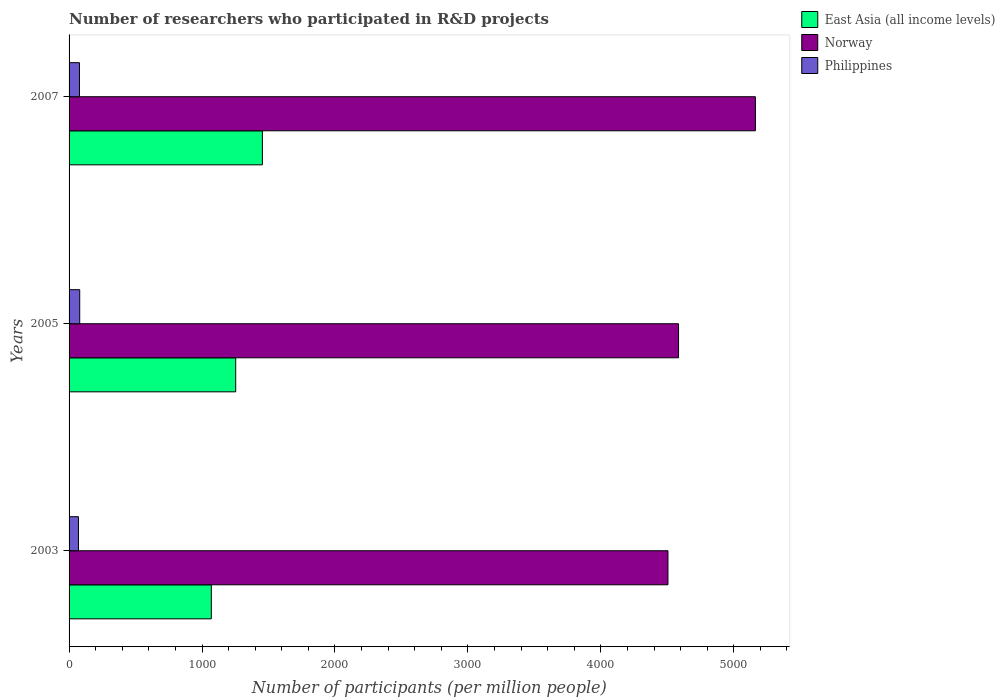How many groups of bars are there?
Ensure brevity in your answer.  3. Are the number of bars on each tick of the Y-axis equal?
Offer a very short reply. Yes. In how many cases, is the number of bars for a given year not equal to the number of legend labels?
Provide a short and direct response. 0. What is the number of researchers who participated in R&D projects in Philippines in 2003?
Make the answer very short. 70.63. Across all years, what is the maximum number of researchers who participated in R&D projects in Norway?
Offer a terse response. 5162.76. Across all years, what is the minimum number of researchers who participated in R&D projects in Philippines?
Provide a short and direct response. 70.63. In which year was the number of researchers who participated in R&D projects in Norway maximum?
Your answer should be very brief. 2007. What is the total number of researchers who participated in R&D projects in Norway in the graph?
Your response must be concise. 1.43e+04. What is the difference between the number of researchers who participated in R&D projects in Philippines in 2003 and that in 2005?
Offer a terse response. -9.43. What is the difference between the number of researchers who participated in R&D projects in East Asia (all income levels) in 2005 and the number of researchers who participated in R&D projects in Philippines in 2007?
Make the answer very short. 1175.22. What is the average number of researchers who participated in R&D projects in East Asia (all income levels) per year?
Provide a succinct answer. 1259.26. In the year 2003, what is the difference between the number of researchers who participated in R&D projects in East Asia (all income levels) and number of researchers who participated in R&D projects in Norway?
Your answer should be compact. -3434.84. In how many years, is the number of researchers who participated in R&D projects in East Asia (all income levels) greater than 200 ?
Ensure brevity in your answer.  3. What is the ratio of the number of researchers who participated in R&D projects in Norway in 2005 to that in 2007?
Ensure brevity in your answer.  0.89. Is the number of researchers who participated in R&D projects in East Asia (all income levels) in 2003 less than that in 2005?
Ensure brevity in your answer.  Yes. Is the difference between the number of researchers who participated in R&D projects in East Asia (all income levels) in 2003 and 2005 greater than the difference between the number of researchers who participated in R&D projects in Norway in 2003 and 2005?
Your answer should be very brief. No. What is the difference between the highest and the second highest number of researchers who participated in R&D projects in Norway?
Make the answer very short. 578.31. What is the difference between the highest and the lowest number of researchers who participated in R&D projects in East Asia (all income levels)?
Provide a short and direct response. 384.15. What does the 3rd bar from the top in 2005 represents?
Ensure brevity in your answer.  East Asia (all income levels). What does the 2nd bar from the bottom in 2007 represents?
Your answer should be very brief. Norway. Are all the bars in the graph horizontal?
Offer a very short reply. Yes. How many years are there in the graph?
Ensure brevity in your answer.  3. What is the difference between two consecutive major ticks on the X-axis?
Give a very brief answer. 1000. Does the graph contain any zero values?
Your response must be concise. No. Where does the legend appear in the graph?
Provide a short and direct response. Top right. How many legend labels are there?
Keep it short and to the point. 3. What is the title of the graph?
Keep it short and to the point. Number of researchers who participated in R&D projects. Does "Zambia" appear as one of the legend labels in the graph?
Offer a terse response. No. What is the label or title of the X-axis?
Provide a short and direct response. Number of participants (per million people). What is the label or title of the Y-axis?
Offer a very short reply. Years. What is the Number of participants (per million people) of East Asia (all income levels) in 2003?
Your answer should be very brief. 1070.1. What is the Number of participants (per million people) in Norway in 2003?
Provide a short and direct response. 4504.94. What is the Number of participants (per million people) of Philippines in 2003?
Your answer should be very brief. 70.63. What is the Number of participants (per million people) of East Asia (all income levels) in 2005?
Your response must be concise. 1253.42. What is the Number of participants (per million people) in Norway in 2005?
Your response must be concise. 4584.46. What is the Number of participants (per million people) of Philippines in 2005?
Provide a succinct answer. 80.05. What is the Number of participants (per million people) in East Asia (all income levels) in 2007?
Provide a succinct answer. 1454.25. What is the Number of participants (per million people) of Norway in 2007?
Ensure brevity in your answer.  5162.76. What is the Number of participants (per million people) of Philippines in 2007?
Your answer should be compact. 78.2. Across all years, what is the maximum Number of participants (per million people) of East Asia (all income levels)?
Provide a short and direct response. 1454.25. Across all years, what is the maximum Number of participants (per million people) in Norway?
Provide a succinct answer. 5162.76. Across all years, what is the maximum Number of participants (per million people) in Philippines?
Offer a very short reply. 80.05. Across all years, what is the minimum Number of participants (per million people) in East Asia (all income levels)?
Make the answer very short. 1070.1. Across all years, what is the minimum Number of participants (per million people) of Norway?
Keep it short and to the point. 4504.94. Across all years, what is the minimum Number of participants (per million people) of Philippines?
Offer a terse response. 70.63. What is the total Number of participants (per million people) of East Asia (all income levels) in the graph?
Give a very brief answer. 3777.77. What is the total Number of participants (per million people) in Norway in the graph?
Offer a very short reply. 1.43e+04. What is the total Number of participants (per million people) in Philippines in the graph?
Make the answer very short. 228.88. What is the difference between the Number of participants (per million people) in East Asia (all income levels) in 2003 and that in 2005?
Your answer should be very brief. -183.32. What is the difference between the Number of participants (per million people) of Norway in 2003 and that in 2005?
Give a very brief answer. -79.51. What is the difference between the Number of participants (per million people) in Philippines in 2003 and that in 2005?
Your answer should be compact. -9.43. What is the difference between the Number of participants (per million people) of East Asia (all income levels) in 2003 and that in 2007?
Your answer should be compact. -384.15. What is the difference between the Number of participants (per million people) in Norway in 2003 and that in 2007?
Provide a succinct answer. -657.82. What is the difference between the Number of participants (per million people) of Philippines in 2003 and that in 2007?
Provide a succinct answer. -7.57. What is the difference between the Number of participants (per million people) of East Asia (all income levels) in 2005 and that in 2007?
Provide a succinct answer. -200.83. What is the difference between the Number of participants (per million people) in Norway in 2005 and that in 2007?
Your response must be concise. -578.31. What is the difference between the Number of participants (per million people) of Philippines in 2005 and that in 2007?
Your answer should be compact. 1.86. What is the difference between the Number of participants (per million people) of East Asia (all income levels) in 2003 and the Number of participants (per million people) of Norway in 2005?
Make the answer very short. -3514.36. What is the difference between the Number of participants (per million people) in East Asia (all income levels) in 2003 and the Number of participants (per million people) in Philippines in 2005?
Give a very brief answer. 990.04. What is the difference between the Number of participants (per million people) of Norway in 2003 and the Number of participants (per million people) of Philippines in 2005?
Keep it short and to the point. 4424.89. What is the difference between the Number of participants (per million people) in East Asia (all income levels) in 2003 and the Number of participants (per million people) in Norway in 2007?
Provide a succinct answer. -4092.66. What is the difference between the Number of participants (per million people) of East Asia (all income levels) in 2003 and the Number of participants (per million people) of Philippines in 2007?
Ensure brevity in your answer.  991.9. What is the difference between the Number of participants (per million people) of Norway in 2003 and the Number of participants (per million people) of Philippines in 2007?
Your response must be concise. 4426.74. What is the difference between the Number of participants (per million people) in East Asia (all income levels) in 2005 and the Number of participants (per million people) in Norway in 2007?
Make the answer very short. -3909.34. What is the difference between the Number of participants (per million people) of East Asia (all income levels) in 2005 and the Number of participants (per million people) of Philippines in 2007?
Provide a short and direct response. 1175.22. What is the difference between the Number of participants (per million people) in Norway in 2005 and the Number of participants (per million people) in Philippines in 2007?
Give a very brief answer. 4506.26. What is the average Number of participants (per million people) of East Asia (all income levels) per year?
Keep it short and to the point. 1259.26. What is the average Number of participants (per million people) of Norway per year?
Give a very brief answer. 4750.72. What is the average Number of participants (per million people) of Philippines per year?
Your answer should be very brief. 76.29. In the year 2003, what is the difference between the Number of participants (per million people) in East Asia (all income levels) and Number of participants (per million people) in Norway?
Provide a short and direct response. -3434.84. In the year 2003, what is the difference between the Number of participants (per million people) of East Asia (all income levels) and Number of participants (per million people) of Philippines?
Your response must be concise. 999.47. In the year 2003, what is the difference between the Number of participants (per million people) in Norway and Number of participants (per million people) in Philippines?
Your answer should be compact. 4434.32. In the year 2005, what is the difference between the Number of participants (per million people) of East Asia (all income levels) and Number of participants (per million people) of Norway?
Keep it short and to the point. -3331.03. In the year 2005, what is the difference between the Number of participants (per million people) of East Asia (all income levels) and Number of participants (per million people) of Philippines?
Give a very brief answer. 1173.37. In the year 2005, what is the difference between the Number of participants (per million people) of Norway and Number of participants (per million people) of Philippines?
Your response must be concise. 4504.4. In the year 2007, what is the difference between the Number of participants (per million people) in East Asia (all income levels) and Number of participants (per million people) in Norway?
Offer a terse response. -3708.51. In the year 2007, what is the difference between the Number of participants (per million people) of East Asia (all income levels) and Number of participants (per million people) of Philippines?
Provide a short and direct response. 1376.05. In the year 2007, what is the difference between the Number of participants (per million people) of Norway and Number of participants (per million people) of Philippines?
Offer a very short reply. 5084.56. What is the ratio of the Number of participants (per million people) in East Asia (all income levels) in 2003 to that in 2005?
Your answer should be compact. 0.85. What is the ratio of the Number of participants (per million people) of Norway in 2003 to that in 2005?
Offer a very short reply. 0.98. What is the ratio of the Number of participants (per million people) in Philippines in 2003 to that in 2005?
Keep it short and to the point. 0.88. What is the ratio of the Number of participants (per million people) in East Asia (all income levels) in 2003 to that in 2007?
Provide a succinct answer. 0.74. What is the ratio of the Number of participants (per million people) of Norway in 2003 to that in 2007?
Make the answer very short. 0.87. What is the ratio of the Number of participants (per million people) of Philippines in 2003 to that in 2007?
Give a very brief answer. 0.9. What is the ratio of the Number of participants (per million people) of East Asia (all income levels) in 2005 to that in 2007?
Provide a succinct answer. 0.86. What is the ratio of the Number of participants (per million people) in Norway in 2005 to that in 2007?
Make the answer very short. 0.89. What is the ratio of the Number of participants (per million people) in Philippines in 2005 to that in 2007?
Your answer should be very brief. 1.02. What is the difference between the highest and the second highest Number of participants (per million people) of East Asia (all income levels)?
Your response must be concise. 200.83. What is the difference between the highest and the second highest Number of participants (per million people) in Norway?
Offer a very short reply. 578.31. What is the difference between the highest and the second highest Number of participants (per million people) of Philippines?
Offer a terse response. 1.86. What is the difference between the highest and the lowest Number of participants (per million people) of East Asia (all income levels)?
Your response must be concise. 384.15. What is the difference between the highest and the lowest Number of participants (per million people) in Norway?
Your answer should be compact. 657.82. What is the difference between the highest and the lowest Number of participants (per million people) in Philippines?
Make the answer very short. 9.43. 